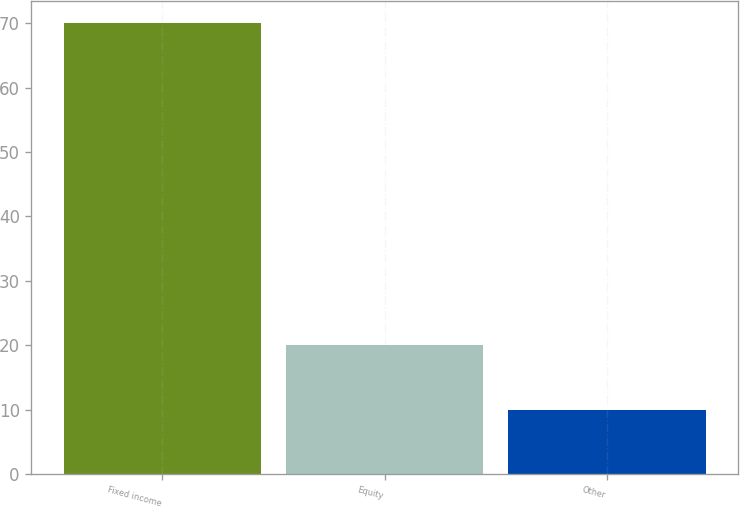Convert chart. <chart><loc_0><loc_0><loc_500><loc_500><bar_chart><fcel>Fixed income<fcel>Equity<fcel>Other<nl><fcel>70<fcel>20<fcel>10<nl></chart> 